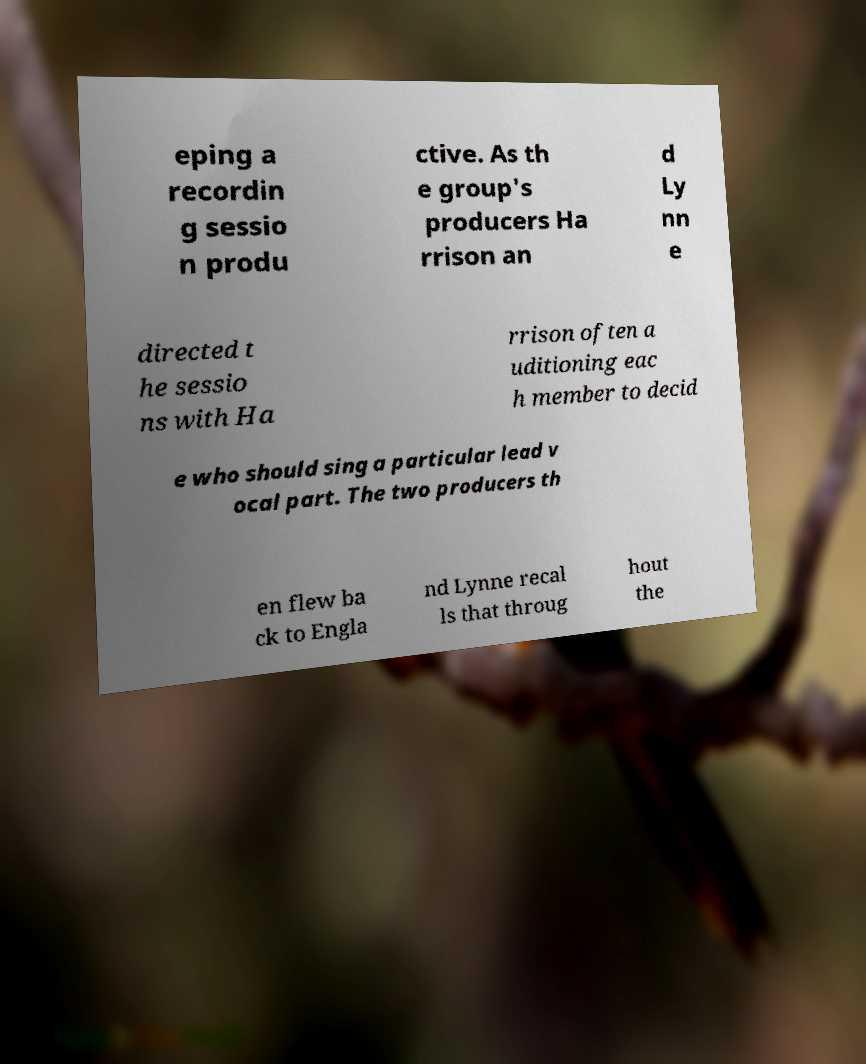For documentation purposes, I need the text within this image transcribed. Could you provide that? eping a recordin g sessio n produ ctive. As th e group's producers Ha rrison an d Ly nn e directed t he sessio ns with Ha rrison often a uditioning eac h member to decid e who should sing a particular lead v ocal part. The two producers th en flew ba ck to Engla nd Lynne recal ls that throug hout the 